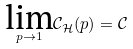Convert formula to latex. <formula><loc_0><loc_0><loc_500><loc_500>\underset { p \rightarrow 1 } { \text {lim} } \mathcal { C } _ { \mathcal { H } } ( p ) = \mathcal { C }</formula> 